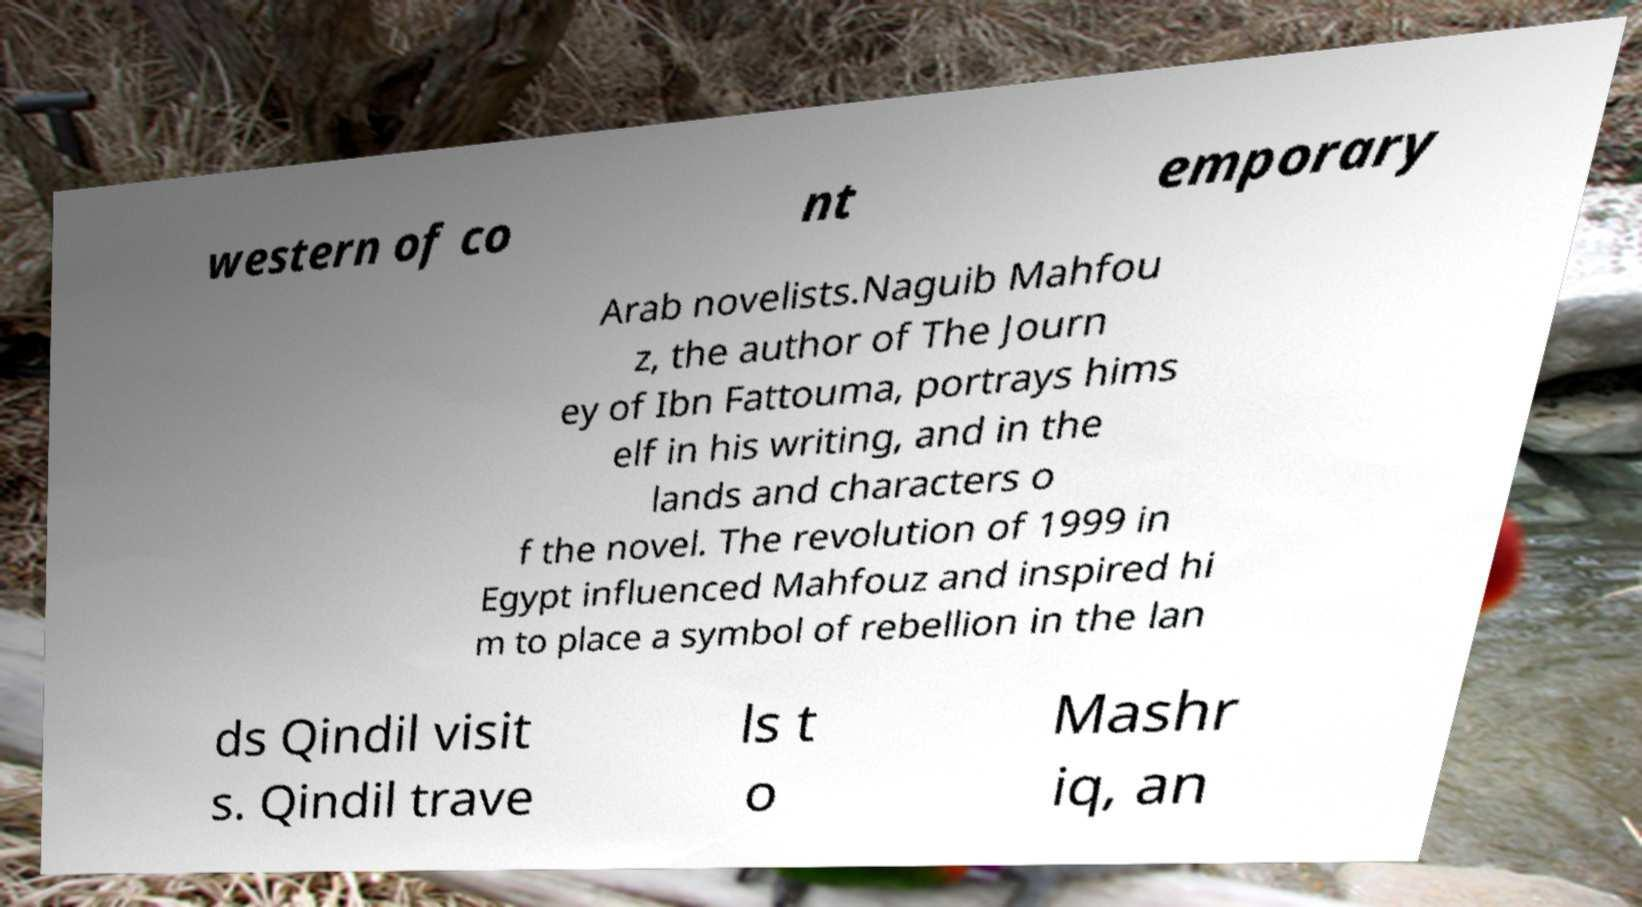I need the written content from this picture converted into text. Can you do that? western of co nt emporary Arab novelists.Naguib Mahfou z, the author of The Journ ey of Ibn Fattouma, portrays hims elf in his writing, and in the lands and characters o f the novel. The revolution of 1999 in Egypt influenced Mahfouz and inspired hi m to place a symbol of rebellion in the lan ds Qindil visit s. Qindil trave ls t o Mashr iq, an 